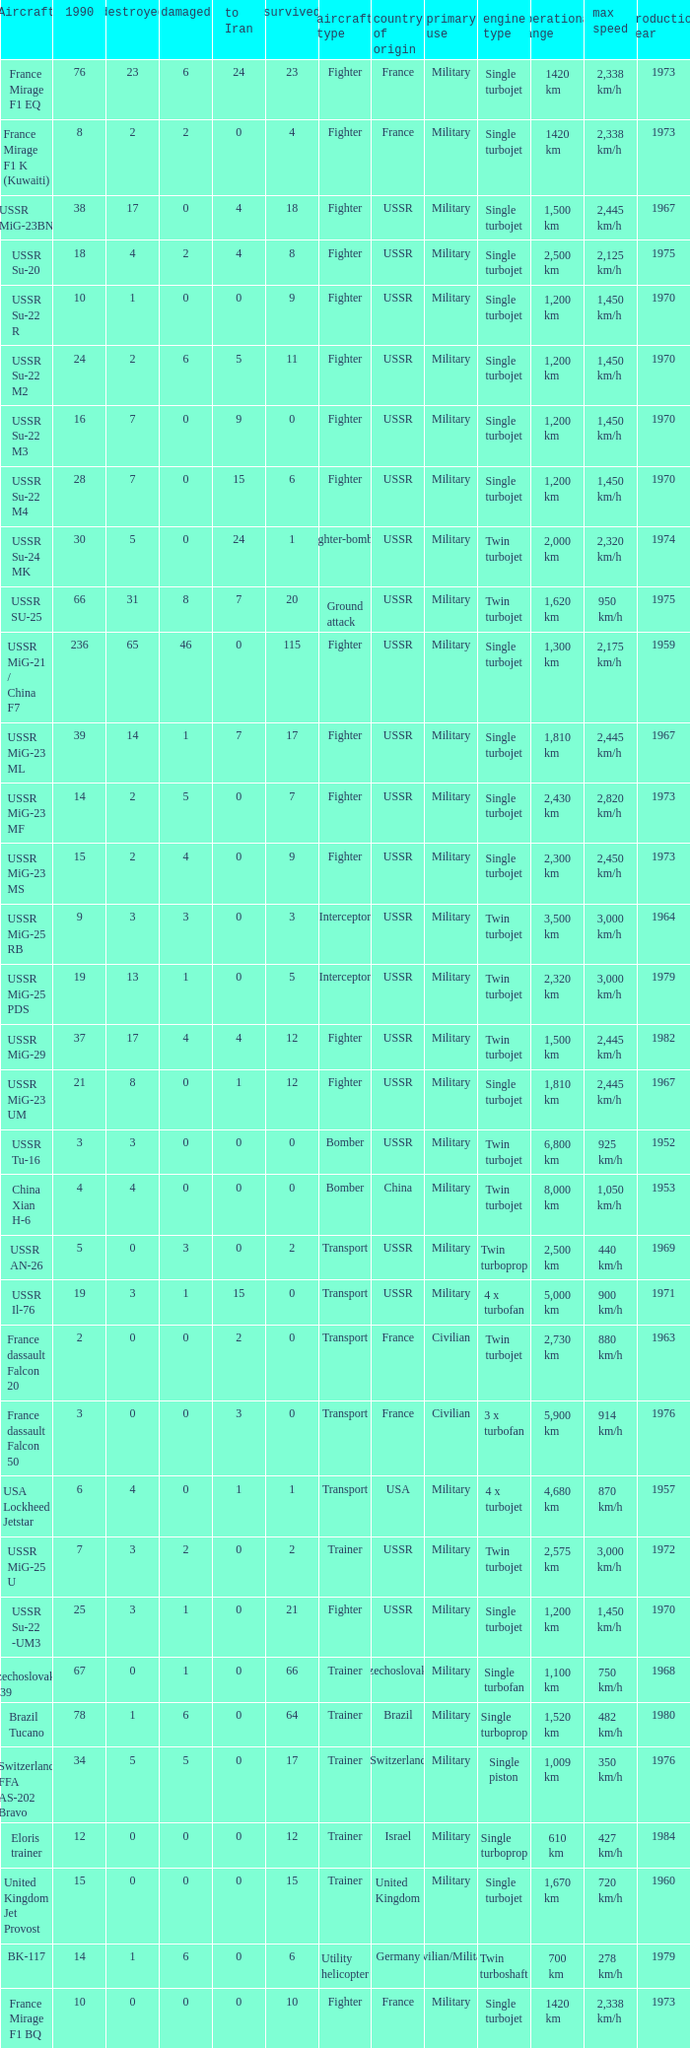If the aircraft was  ussr mig-25 rb how many were destroyed? 3.0. 